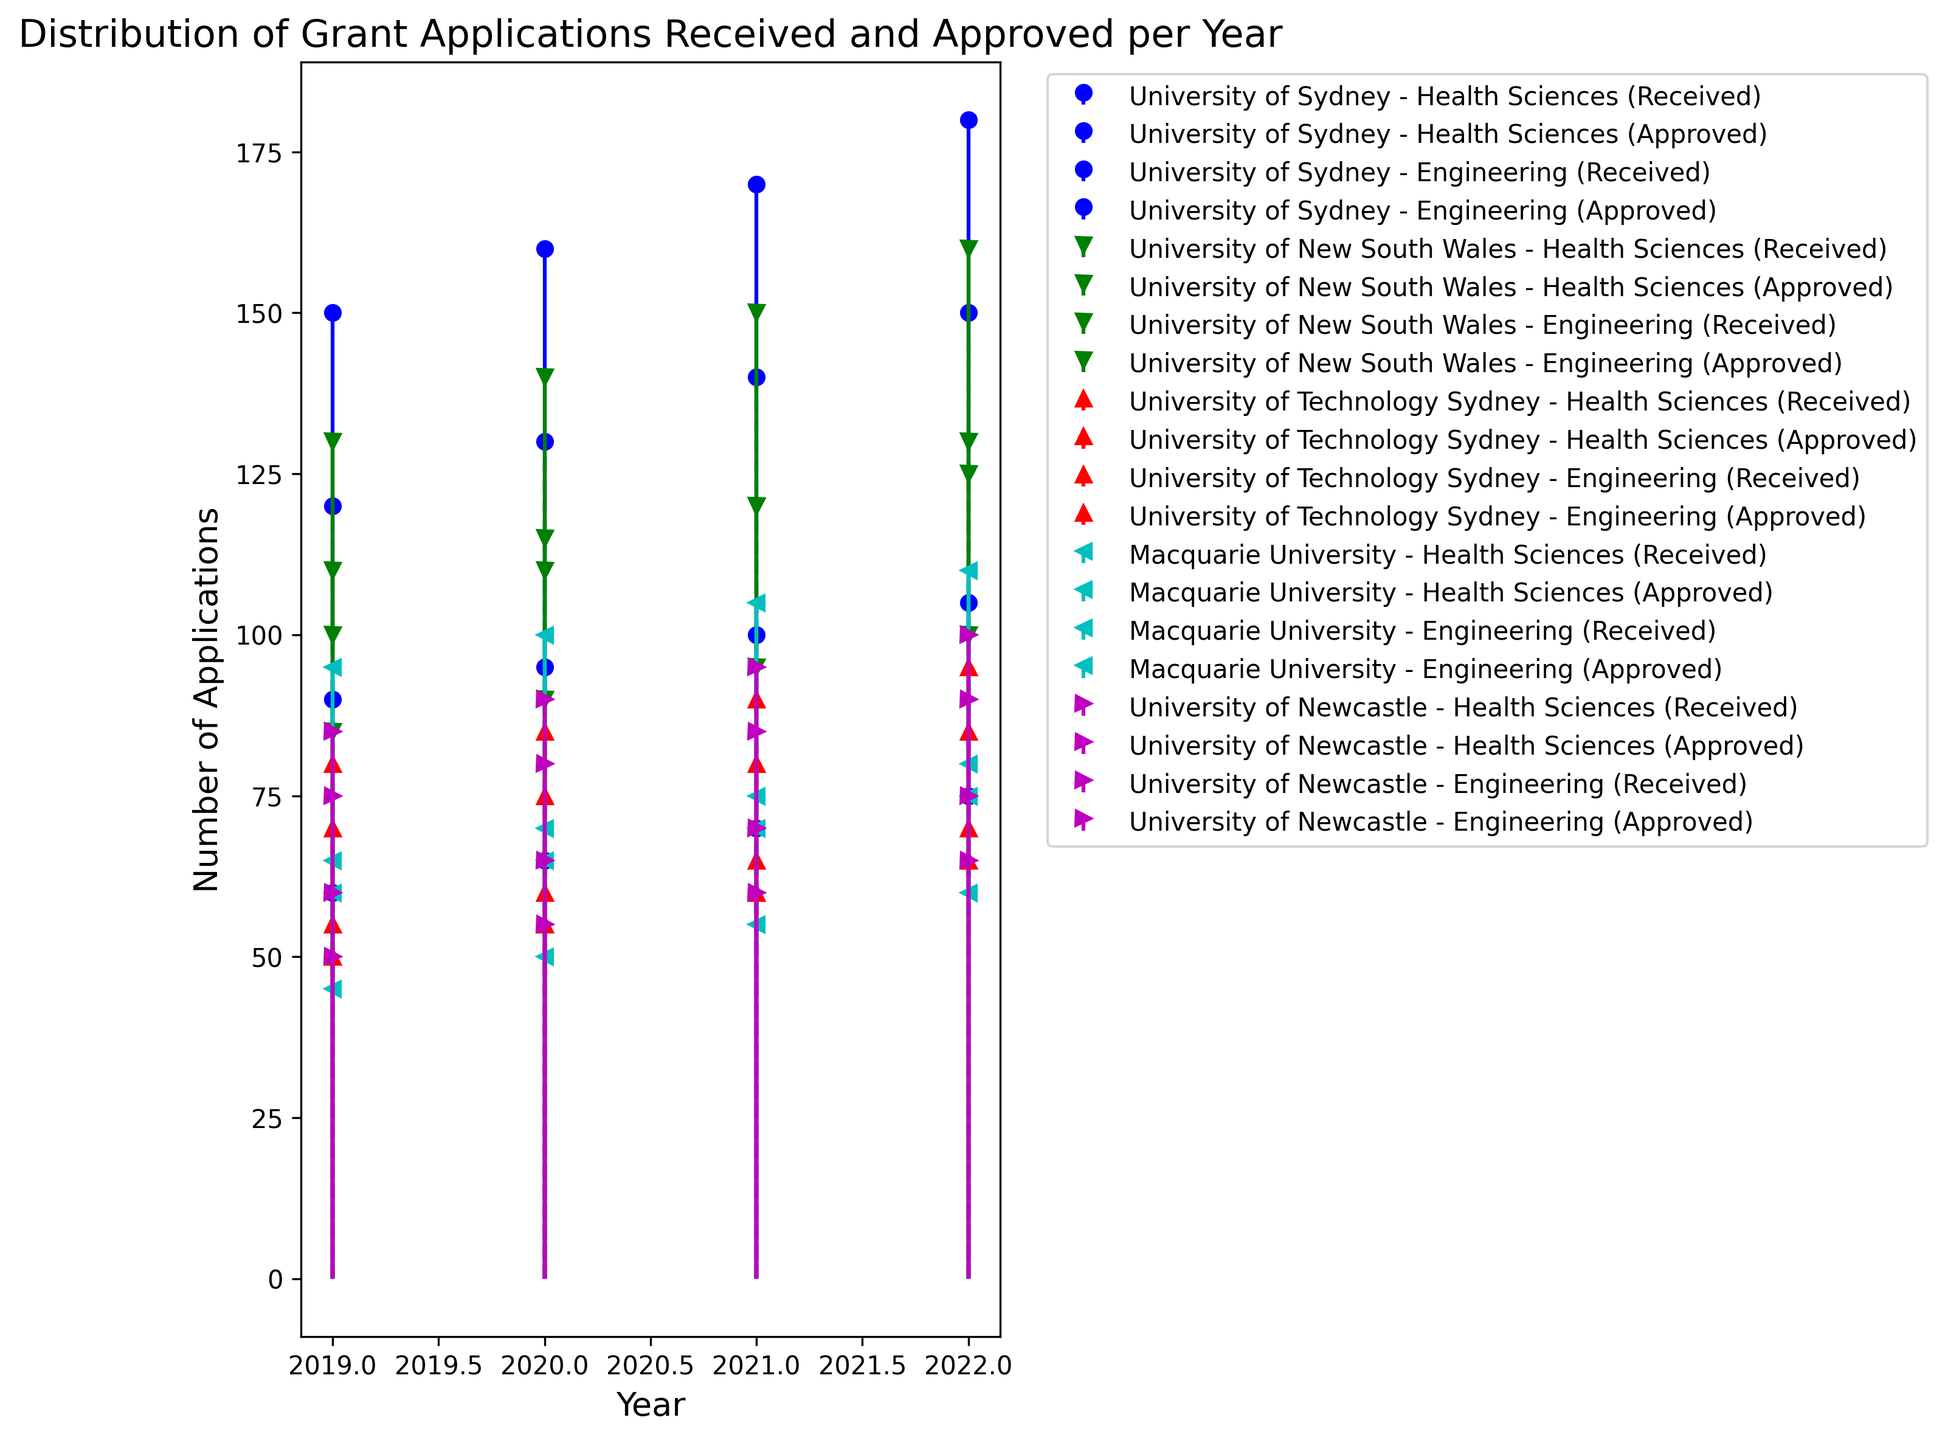What trend can you observe for the number of applications received in Health Sciences by the University of Sydney from 2019 to 2022? First, identify the data points for applications received in Health Sciences by the University of Sydney for each year from 2019 to 2022. The values are: 2019 = 150, 2020 = 160, 2021 = 170, 2022 = 180. The trend shows an increasing pattern each year.
Answer: Increasing Which university had the most applications received for Engineering in 2021? Look at the number of applications received for Engineering by all universities in 2021. Compare these values: University of Sydney = 100, University of New South Wales = 120, University of Technology Sydney = 80, Macquarie University = 70, University of Newcastle = 85. The University of New South Wales had the most applications received.
Answer: University of New South Wales How many additional applications were approved compared to the previous year for Health Sciences at Macquarie University in 2021? First, retrieve the number of applications approved in 2020 (70) and 2021 (75) for Health Sciences at Macquarie University. Subtract the 2020 value from the 2021 value: 75 - 70 = 5.
Answer: 5 What was the trend for the total number of applications approved across all universities for Health Sciences from 2020 to 2021? Sum the approved applications for Health Sciences across all universities for 2020 and 2021. 2020: 130 + 110 + 55 + 70 + 65 = 430, 2021: 140 + 120 + 60 + 75 + 70 = 465. Compare 430 vs 465: there is an increase.
Answer: Increasing Which university showed the lowest number of applications received for Health Sciences in 2020? Compare the values for 2020: University of Sydney = 160, University of New South Wales = 140, University of Technology Sydney = 85, Macquarie University = 100, University of Newcastle = 90. The lowest number is 85, by the University of Technology Sydney.
Answer: University of Technology Sydney In which year did the University of Newcastle have the same number of applications approved for Health Sciences and Engineering? Find the years where the number of applications approved for Health Sciences equals that of Engineering for the University of Newcastle. In 2020, both were 65.
Answer: 2020 Did any university receive more than 200 applications for Health Sciences in any given year? Check the number of applications received for Health Sciences by each university across all years. The highest values are: University of Sydney (2019: 150, 2020: 160, 2021: 170, 2022: 180), University of New South Wales (2019: 130, 2020: 140, 2021: 150, 2022: 160). No values exceed 200.
Answer: No Compare the number of applications received for Engineering in 2022 versus 2021 for the University of Technology Sydney. What is the percentage change? Find the values for 2021 (80) and 2022 (85). Calculate the percentage change: ((85 - 80) / 80) * 100 = 6.25%.
Answer: 6.25% Across all universities, which research area (Health Sciences or Engineering) had more applications approved in 2019? Sum the approved applications for each research area in 2019: Health Sciences = 120 + 100 + 50 + 65 + 60 = 395, Engineering = 60 + 85 + 55 + 45 + 50 = 295. Health Sciences had more approvals.
Answer: Health Sciences 